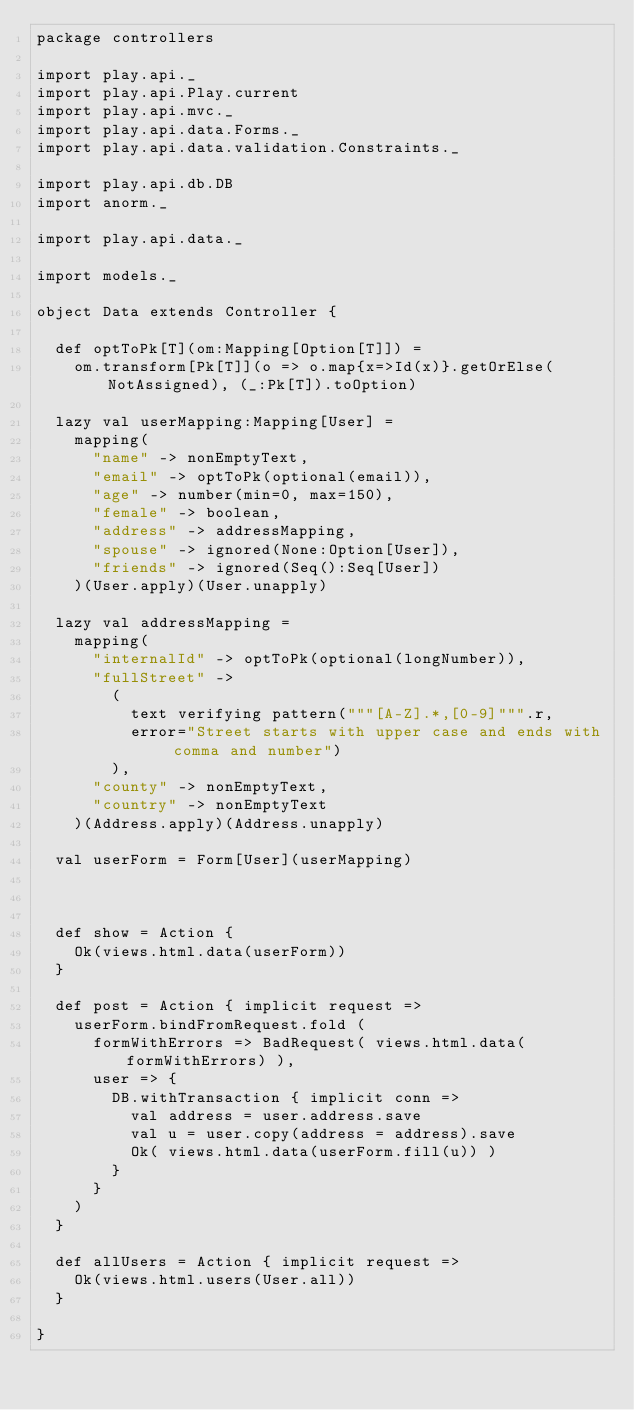Convert code to text. <code><loc_0><loc_0><loc_500><loc_500><_Scala_>package controllers

import play.api._
import play.api.Play.current
import play.api.mvc._
import play.api.data.Forms._
import play.api.data.validation.Constraints._

import play.api.db.DB
import anorm._

import play.api.data._

import models._

object Data extends Controller {

  def optToPk[T](om:Mapping[Option[T]]) =
    om.transform[Pk[T]](o => o.map{x=>Id(x)}.getOrElse(NotAssigned), (_:Pk[T]).toOption)

  lazy val userMapping:Mapping[User] =
    mapping(
      "name" -> nonEmptyText,
      "email" -> optToPk(optional(email)),
      "age" -> number(min=0, max=150),
      "female" -> boolean,
      "address" -> addressMapping,
      "spouse" -> ignored(None:Option[User]),
      "friends" -> ignored(Seq():Seq[User])
    )(User.apply)(User.unapply)

  lazy val addressMapping =
    mapping(
      "internalId" -> optToPk(optional(longNumber)),
      "fullStreet" ->
        (
          text verifying pattern("""[A-Z].*,[0-9]""".r,
          error="Street starts with upper case and ends with comma and number")
        ),
      "county" -> nonEmptyText,
      "country" -> nonEmptyText
    )(Address.apply)(Address.unapply)

  val userForm = Form[User](userMapping)



  def show = Action {
    Ok(views.html.data(userForm))
  }

  def post = Action { implicit request =>
    userForm.bindFromRequest.fold (
      formWithErrors => BadRequest( views.html.data(formWithErrors) ),
      user => {
        DB.withTransaction { implicit conn =>
          val address = user.address.save
          val u = user.copy(address = address).save
          Ok( views.html.data(userForm.fill(u)) )
        }
      }
    )
  }

  def allUsers = Action { implicit request =>
    Ok(views.html.users(User.all))
  }

}</code> 